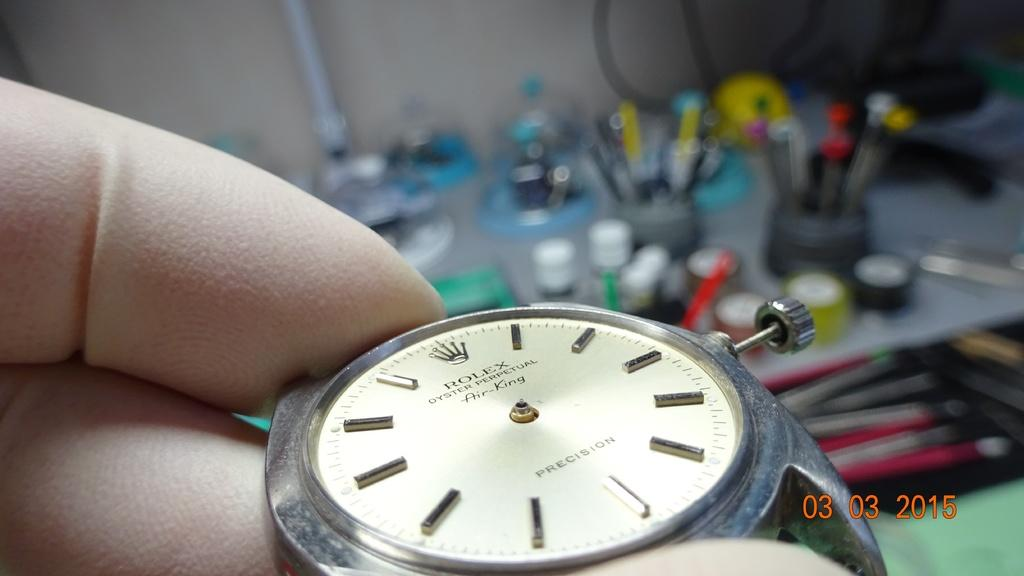<image>
Summarize the visual content of the image. A hand holds an antique Rolex Air King watch in its hand 